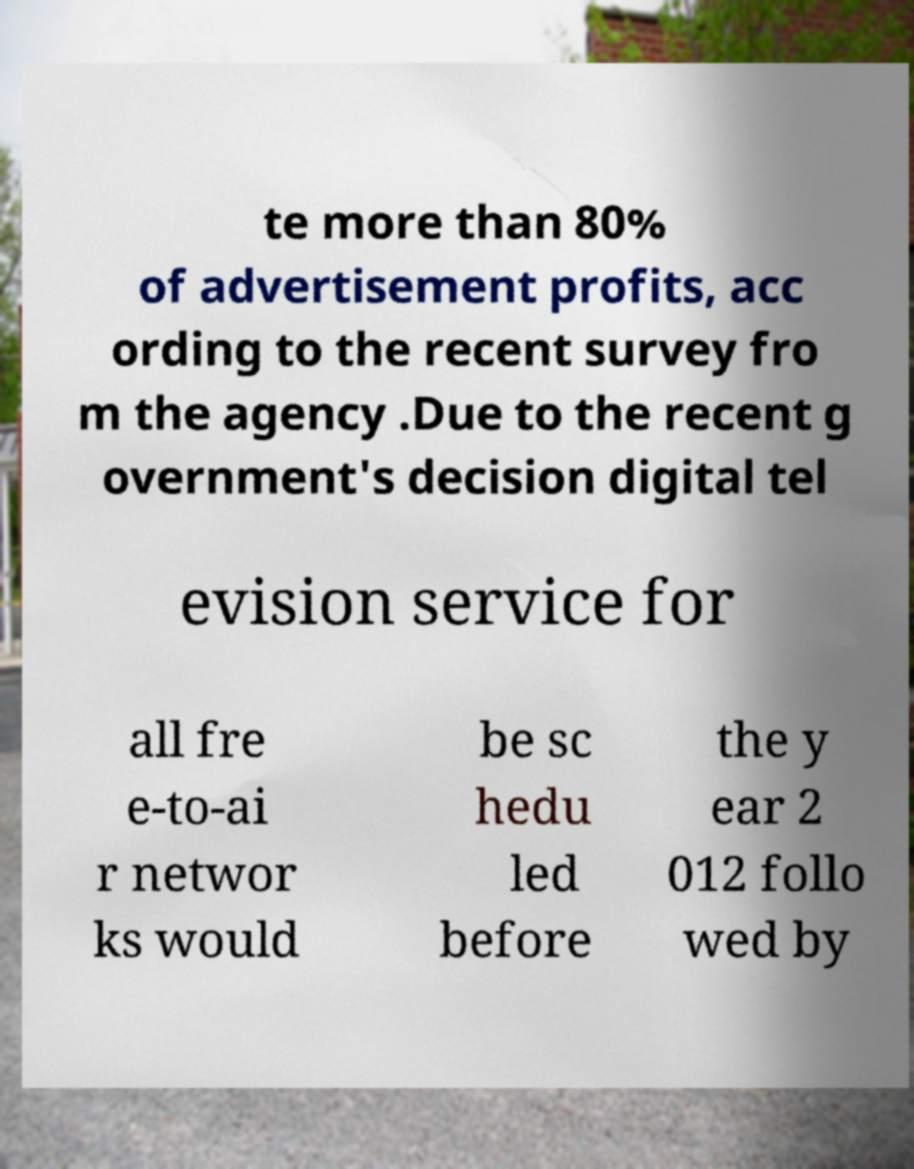What messages or text are displayed in this image? I need them in a readable, typed format. te more than 80% of advertisement profits, acc ording to the recent survey fro m the agency .Due to the recent g overnment's decision digital tel evision service for all fre e-to-ai r networ ks would be sc hedu led before the y ear 2 012 follo wed by 